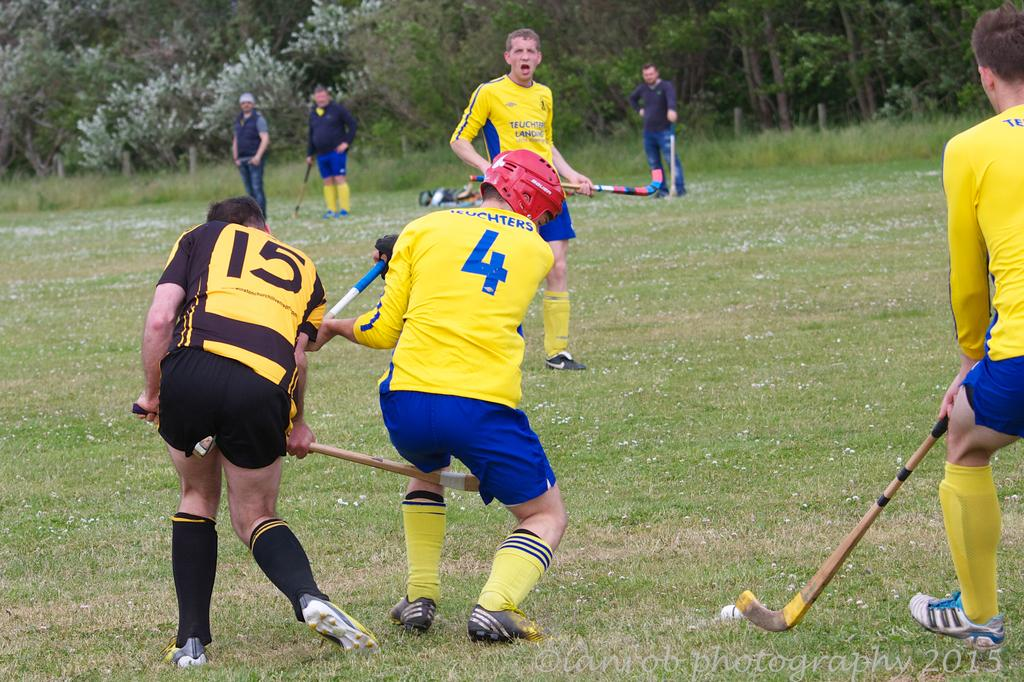<image>
Present a compact description of the photo's key features. A hockey game with a ball on grass is being played by players with the numbers 4 and 15 on their jerseys. 